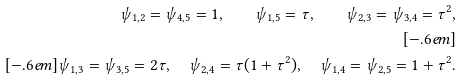<formula> <loc_0><loc_0><loc_500><loc_500>\psi _ { 1 , 2 } = \psi _ { 4 , 5 } = 1 , \quad \psi _ { 1 , 5 } = \tau , \quad \psi _ { 2 , 3 } = \psi _ { 3 , 4 } = \tau ^ { 2 } , \\ [ - . 6 e m ] \\ [ - . 6 e m ] \psi _ { 1 , 3 } = \psi _ { 3 , 5 } = 2 \tau , \quad \psi _ { 2 , 4 } = \tau ( 1 + \tau ^ { 2 } ) , \quad \psi _ { 1 , 4 } = \psi _ { 2 , 5 } = 1 + \tau ^ { 2 } .</formula> 